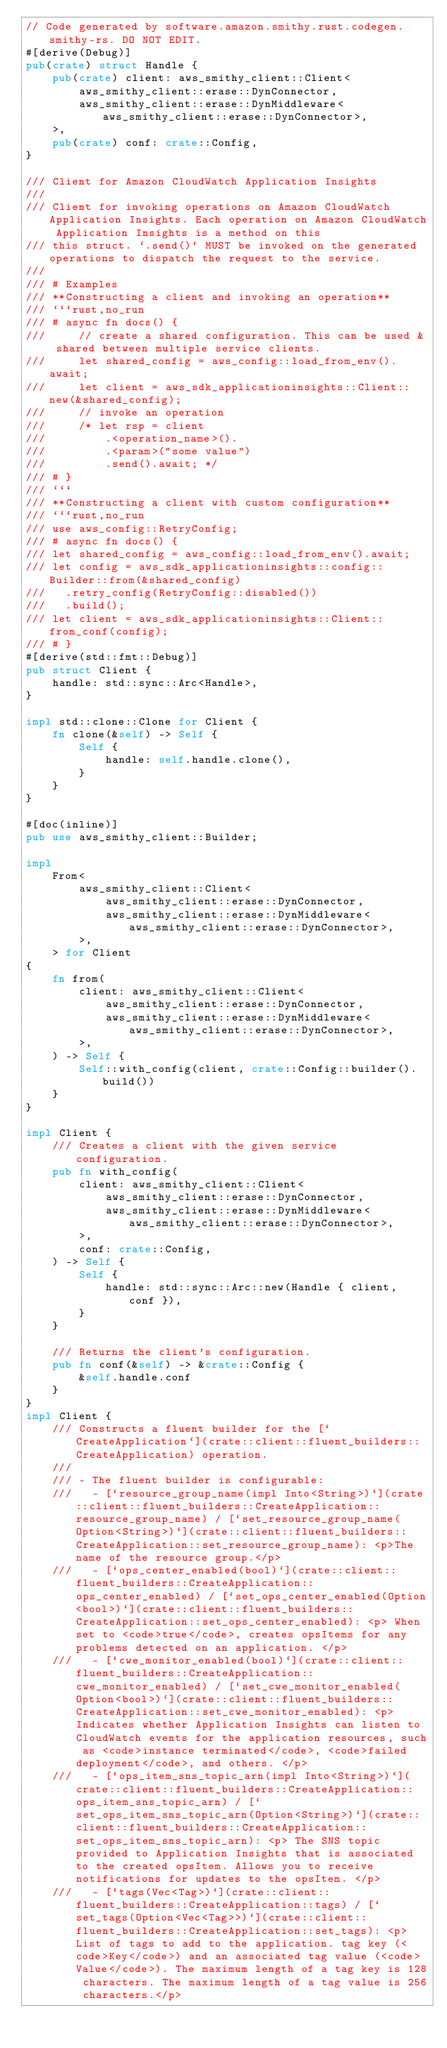Convert code to text. <code><loc_0><loc_0><loc_500><loc_500><_Rust_>// Code generated by software.amazon.smithy.rust.codegen.smithy-rs. DO NOT EDIT.
#[derive(Debug)]
pub(crate) struct Handle {
    pub(crate) client: aws_smithy_client::Client<
        aws_smithy_client::erase::DynConnector,
        aws_smithy_client::erase::DynMiddleware<aws_smithy_client::erase::DynConnector>,
    >,
    pub(crate) conf: crate::Config,
}

/// Client for Amazon CloudWatch Application Insights
///
/// Client for invoking operations on Amazon CloudWatch Application Insights. Each operation on Amazon CloudWatch Application Insights is a method on this
/// this struct. `.send()` MUST be invoked on the generated operations to dispatch the request to the service.
///
/// # Examples
/// **Constructing a client and invoking an operation**
/// ```rust,no_run
/// # async fn docs() {
///     // create a shared configuration. This can be used & shared between multiple service clients.
///     let shared_config = aws_config::load_from_env().await;
///     let client = aws_sdk_applicationinsights::Client::new(&shared_config);
///     // invoke an operation
///     /* let rsp = client
///         .<operation_name>().
///         .<param>("some value")
///         .send().await; */
/// # }
/// ```
/// **Constructing a client with custom configuration**
/// ```rust,no_run
/// use aws_config::RetryConfig;
/// # async fn docs() {
/// let shared_config = aws_config::load_from_env().await;
/// let config = aws_sdk_applicationinsights::config::Builder::from(&shared_config)
///   .retry_config(RetryConfig::disabled())
///   .build();
/// let client = aws_sdk_applicationinsights::Client::from_conf(config);
/// # }
#[derive(std::fmt::Debug)]
pub struct Client {
    handle: std::sync::Arc<Handle>,
}

impl std::clone::Clone for Client {
    fn clone(&self) -> Self {
        Self {
            handle: self.handle.clone(),
        }
    }
}

#[doc(inline)]
pub use aws_smithy_client::Builder;

impl
    From<
        aws_smithy_client::Client<
            aws_smithy_client::erase::DynConnector,
            aws_smithy_client::erase::DynMiddleware<aws_smithy_client::erase::DynConnector>,
        >,
    > for Client
{
    fn from(
        client: aws_smithy_client::Client<
            aws_smithy_client::erase::DynConnector,
            aws_smithy_client::erase::DynMiddleware<aws_smithy_client::erase::DynConnector>,
        >,
    ) -> Self {
        Self::with_config(client, crate::Config::builder().build())
    }
}

impl Client {
    /// Creates a client with the given service configuration.
    pub fn with_config(
        client: aws_smithy_client::Client<
            aws_smithy_client::erase::DynConnector,
            aws_smithy_client::erase::DynMiddleware<aws_smithy_client::erase::DynConnector>,
        >,
        conf: crate::Config,
    ) -> Self {
        Self {
            handle: std::sync::Arc::new(Handle { client, conf }),
        }
    }

    /// Returns the client's configuration.
    pub fn conf(&self) -> &crate::Config {
        &self.handle.conf
    }
}
impl Client {
    /// Constructs a fluent builder for the [`CreateApplication`](crate::client::fluent_builders::CreateApplication) operation.
    ///
    /// - The fluent builder is configurable:
    ///   - [`resource_group_name(impl Into<String>)`](crate::client::fluent_builders::CreateApplication::resource_group_name) / [`set_resource_group_name(Option<String>)`](crate::client::fluent_builders::CreateApplication::set_resource_group_name): <p>The name of the resource group.</p>
    ///   - [`ops_center_enabled(bool)`](crate::client::fluent_builders::CreateApplication::ops_center_enabled) / [`set_ops_center_enabled(Option<bool>)`](crate::client::fluent_builders::CreateApplication::set_ops_center_enabled): <p> When set to <code>true</code>, creates opsItems for any problems detected on an application. </p>
    ///   - [`cwe_monitor_enabled(bool)`](crate::client::fluent_builders::CreateApplication::cwe_monitor_enabled) / [`set_cwe_monitor_enabled(Option<bool>)`](crate::client::fluent_builders::CreateApplication::set_cwe_monitor_enabled): <p> Indicates whether Application Insights can listen to CloudWatch events for the application resources, such as <code>instance terminated</code>, <code>failed deployment</code>, and others. </p>
    ///   - [`ops_item_sns_topic_arn(impl Into<String>)`](crate::client::fluent_builders::CreateApplication::ops_item_sns_topic_arn) / [`set_ops_item_sns_topic_arn(Option<String>)`](crate::client::fluent_builders::CreateApplication::set_ops_item_sns_topic_arn): <p> The SNS topic provided to Application Insights that is associated to the created opsItem. Allows you to receive notifications for updates to the opsItem. </p>
    ///   - [`tags(Vec<Tag>)`](crate::client::fluent_builders::CreateApplication::tags) / [`set_tags(Option<Vec<Tag>>)`](crate::client::fluent_builders::CreateApplication::set_tags): <p>List of tags to add to the application. tag key (<code>Key</code>) and an associated tag value (<code>Value</code>). The maximum length of a tag key is 128 characters. The maximum length of a tag value is 256 characters.</p></code> 